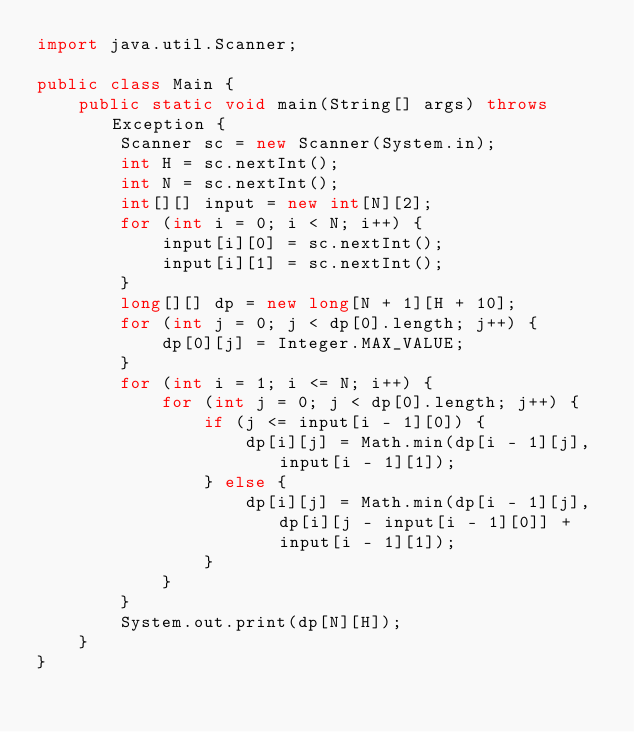Convert code to text. <code><loc_0><loc_0><loc_500><loc_500><_Java_>import java.util.Scanner;

public class Main {
	public static void main(String[] args) throws Exception {
		Scanner sc = new Scanner(System.in);
		int H = sc.nextInt();
		int N = sc.nextInt();
		int[][] input = new int[N][2];
		for (int i = 0; i < N; i++) {
			input[i][0] = sc.nextInt();
			input[i][1] = sc.nextInt();
		}
		long[][] dp = new long[N + 1][H + 10];
		for (int j = 0; j < dp[0].length; j++) {
			dp[0][j] = Integer.MAX_VALUE;
		}
		for (int i = 1; i <= N; i++) {
			for (int j = 0; j < dp[0].length; j++) {
				if (j <= input[i - 1][0]) {
					dp[i][j] = Math.min(dp[i - 1][j], input[i - 1][1]);
				} else {
					dp[i][j] = Math.min(dp[i - 1][j], dp[i][j - input[i - 1][0]] + input[i - 1][1]);
				}
			}
		}
		System.out.print(dp[N][H]);
	}
}</code> 